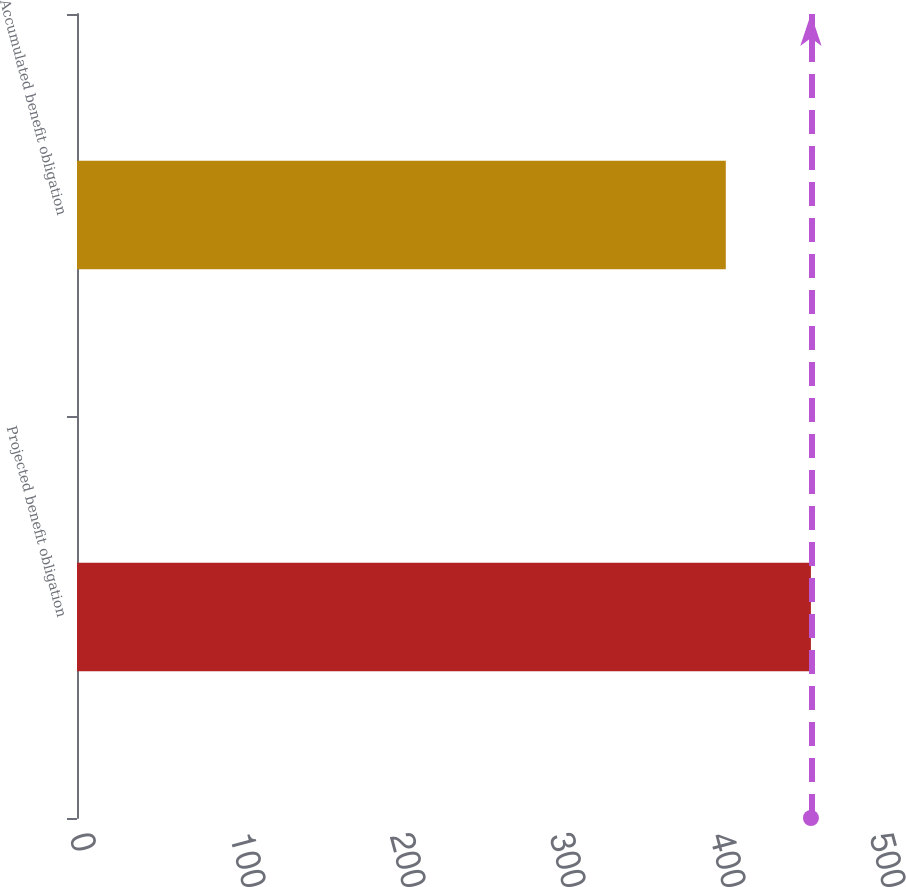<chart> <loc_0><loc_0><loc_500><loc_500><bar_chart><fcel>Projected benefit obligation<fcel>Accumulated benefit obligation<nl><fcel>458.7<fcel>405.5<nl></chart> 